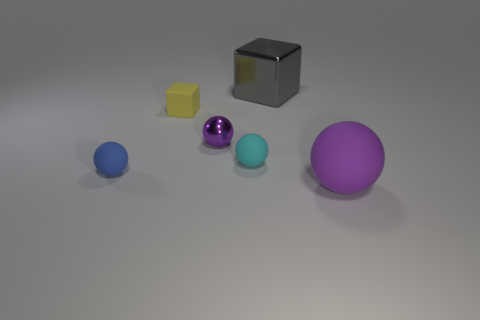How many purple balls must be subtracted to get 1 purple balls? 1 Subtract 1 balls. How many balls are left? 3 Add 1 small purple objects. How many objects exist? 7 Subtract all cubes. How many objects are left? 4 Subtract 1 blue spheres. How many objects are left? 5 Subtract all blue cylinders. Subtract all metal things. How many objects are left? 4 Add 5 blue balls. How many blue balls are left? 6 Add 2 small cubes. How many small cubes exist? 3 